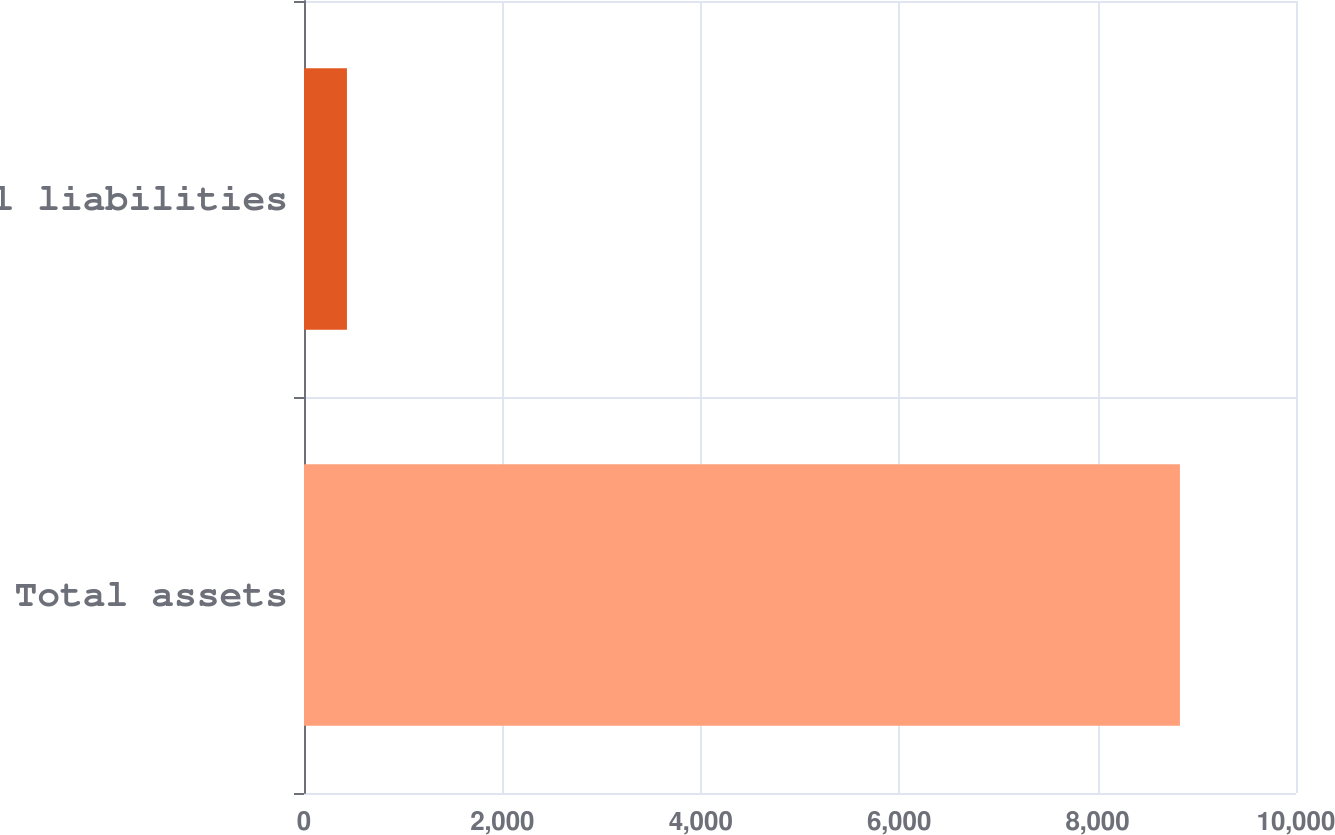Convert chart to OTSL. <chart><loc_0><loc_0><loc_500><loc_500><bar_chart><fcel>Total assets<fcel>Total liabilities<nl><fcel>8830<fcel>433<nl></chart> 